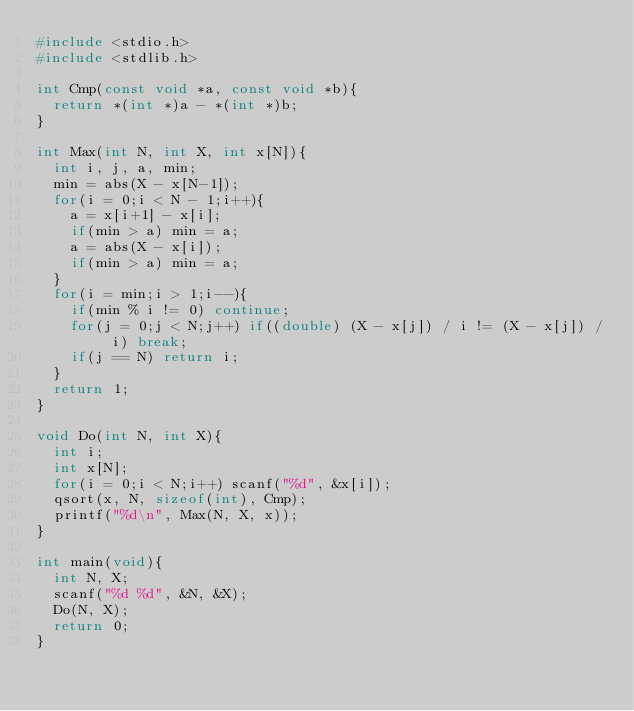Convert code to text. <code><loc_0><loc_0><loc_500><loc_500><_C_>#include <stdio.h>
#include <stdlib.h>

int Cmp(const void *a, const void *b){
  return *(int *)a - *(int *)b;
}

int Max(int N, int X, int x[N]){
  int i, j, a, min;
  min = abs(X - x[N-1]);
  for(i = 0;i < N - 1;i++){
    a = x[i+1] - x[i];
    if(min > a) min = a;
    a = abs(X - x[i]);
    if(min > a) min = a;
  }
  for(i = min;i > 1;i--){
    if(min % i != 0) continue;
    for(j = 0;j < N;j++) if((double) (X - x[j]) / i != (X - x[j]) / i) break;
    if(j == N) return i;
  }
  return 1;
}

void Do(int N, int X){
  int i;
  int x[N];
  for(i = 0;i < N;i++) scanf("%d", &x[i]);
  qsort(x, N, sizeof(int), Cmp);
  printf("%d\n", Max(N, X, x));
}

int main(void){
  int N, X;
  scanf("%d %d", &N, &X);
  Do(N, X);
  return 0;
}</code> 